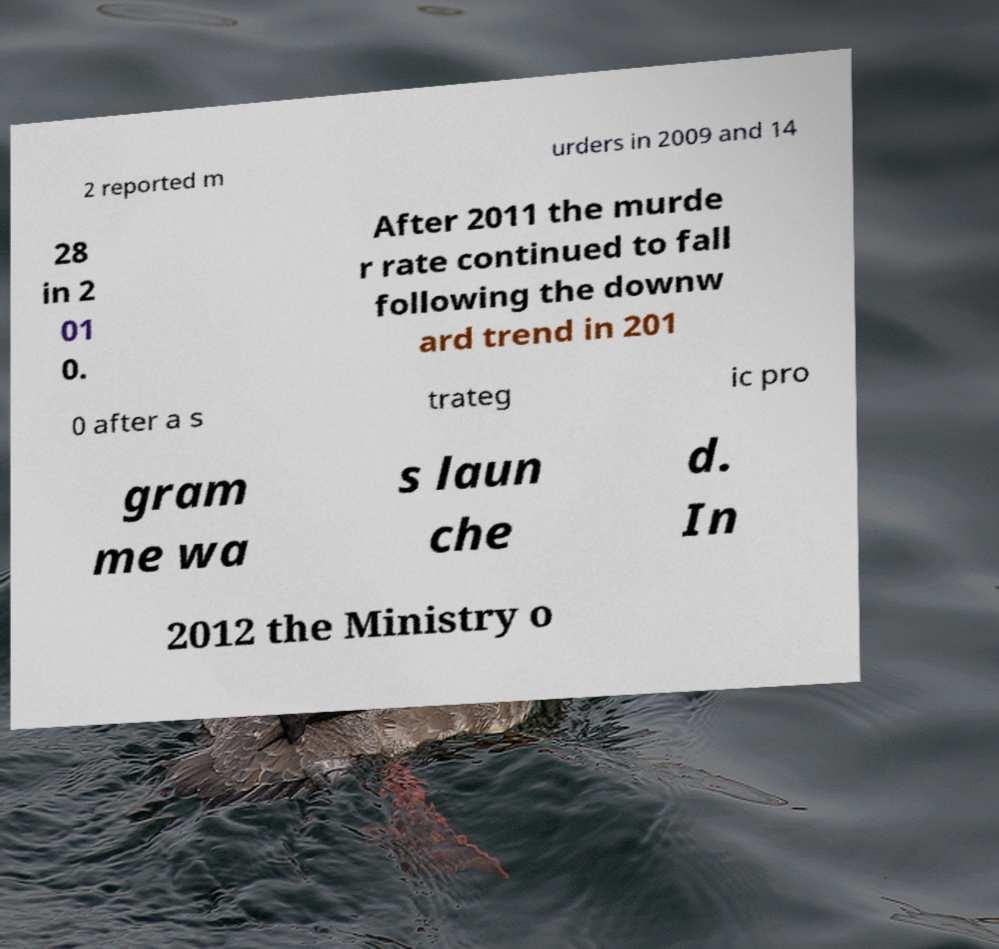Could you assist in decoding the text presented in this image and type it out clearly? 2 reported m urders in 2009 and 14 28 in 2 01 0. After 2011 the murde r rate continued to fall following the downw ard trend in 201 0 after a s trateg ic pro gram me wa s laun che d. In 2012 the Ministry o 